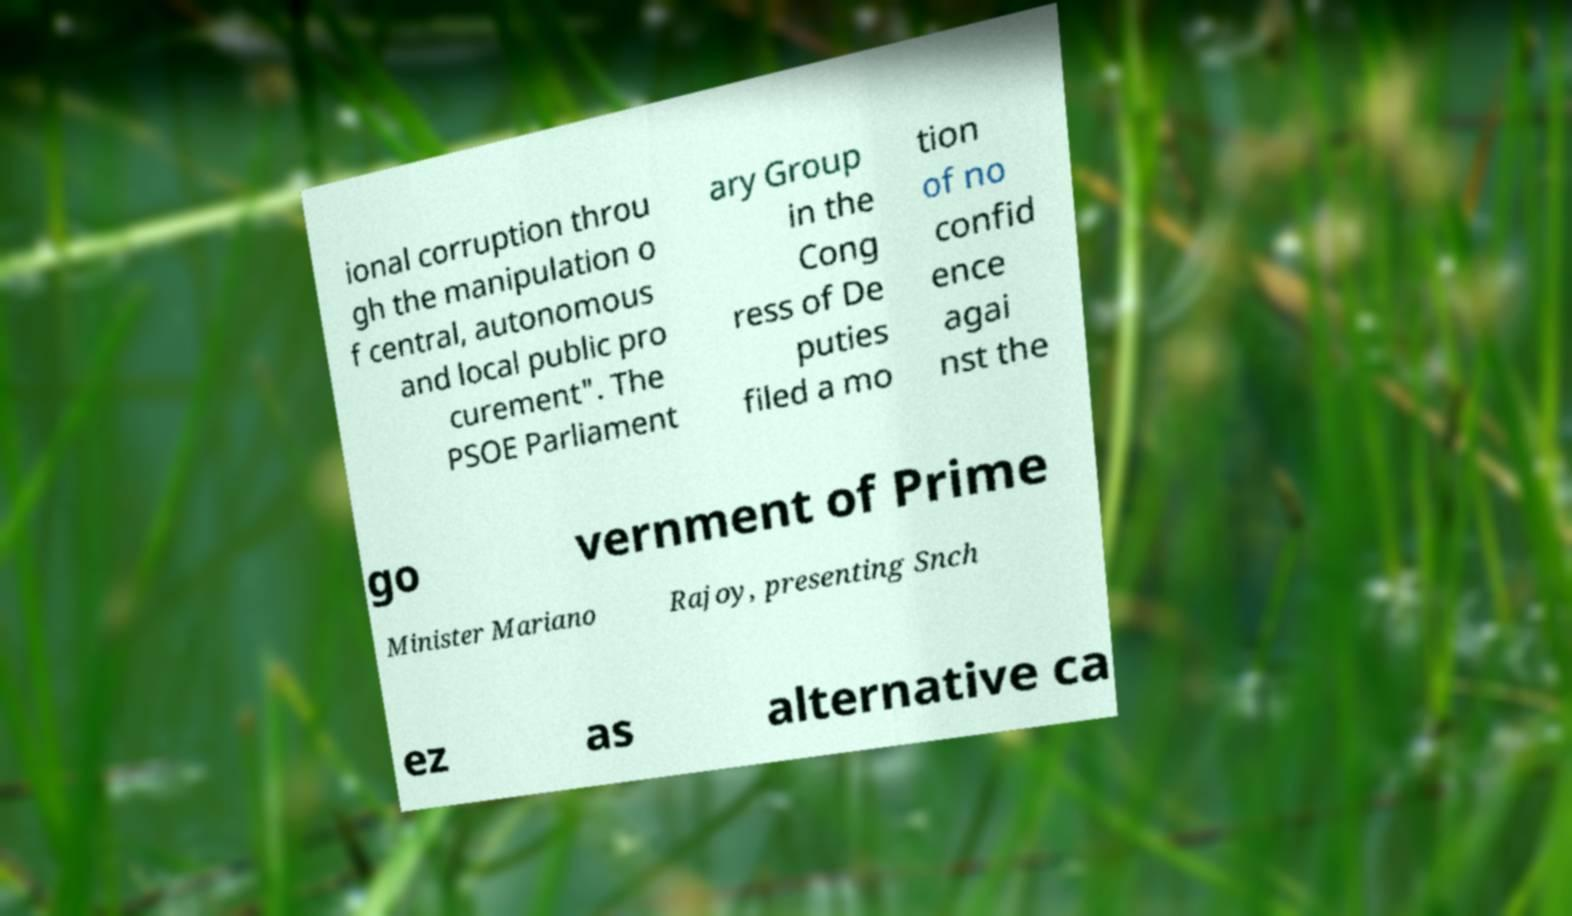Can you read and provide the text displayed in the image?This photo seems to have some interesting text. Can you extract and type it out for me? ional corruption throu gh the manipulation o f central, autonomous and local public pro curement". The PSOE Parliament ary Group in the Cong ress of De puties filed a mo tion of no confid ence agai nst the go vernment of Prime Minister Mariano Rajoy, presenting Snch ez as alternative ca 